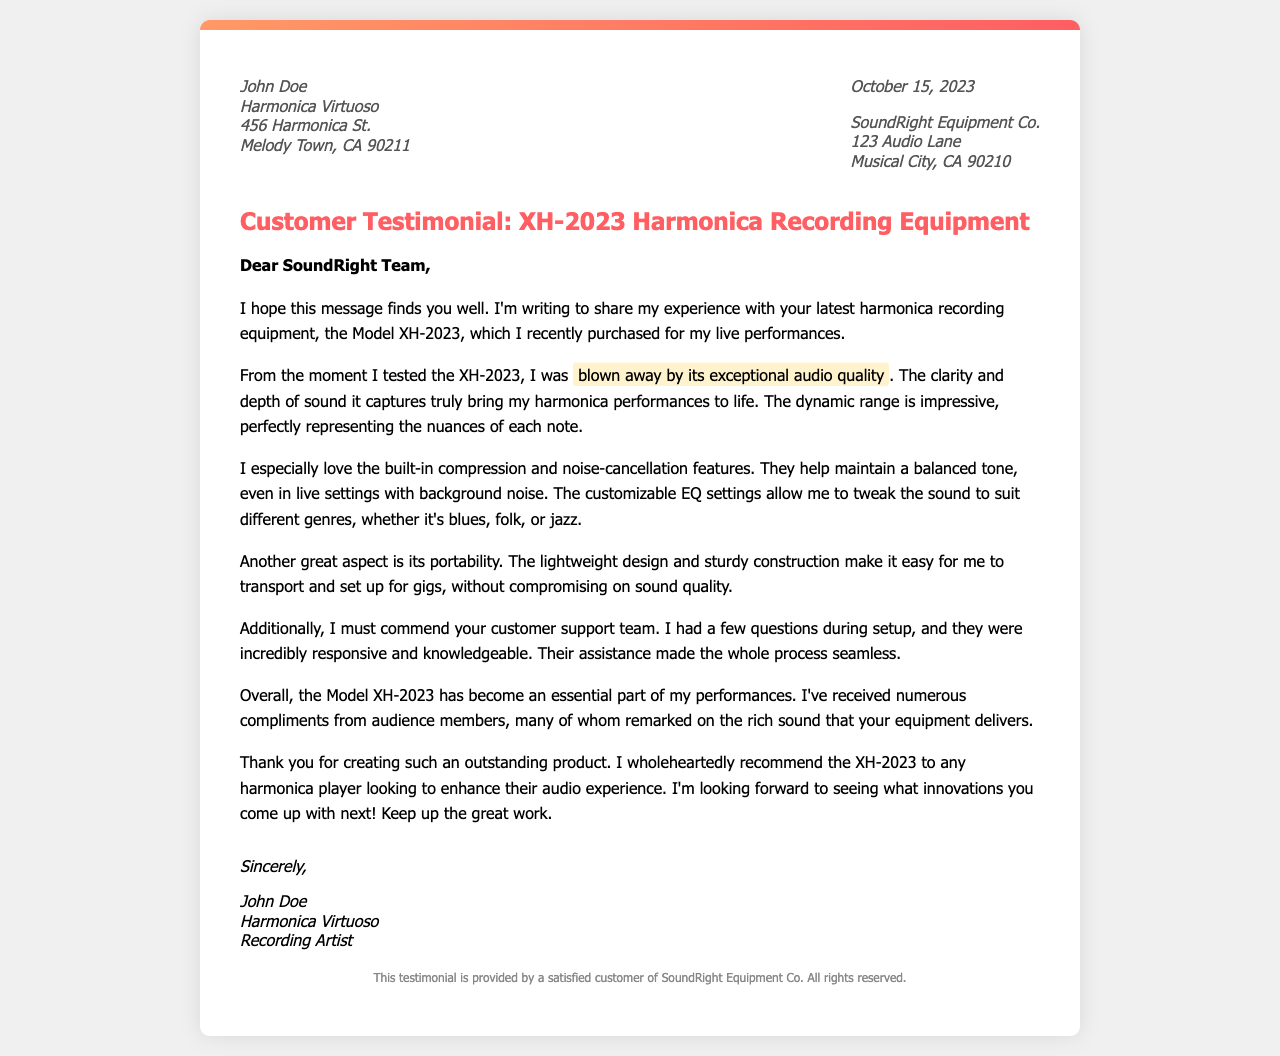What is the name of the testimonial author? The testimonial author is John Doe, as stated at the beginning of the letter.
Answer: John Doe What is the model of the recording equipment mentioned? The recording equipment mentioned in the letter is the Model XH-2023.
Answer: XH-2023 What features of the XH-2023 are highlighted in the testimonial? The notable features include exceptional audio quality, built-in compression, noise-cancellation, and customizable EQ settings, as mentioned in the content.
Answer: Exceptional audio quality, built-in compression, noise-cancellation, customizable EQ settings When was the testimonial written? The date mentioned in the letter is October 15, 2023.
Answer: October 15, 2023 Who is the intended recipient of the letter? The letter is addressed to the SoundRight Team, indicating that they are the recipients.
Answer: SoundRight Team What does the author express gratitude for in the letter? The author expresses gratitude for creating an outstanding product, specifically mentioning the Model XH-2023 harmonica recording equipment.
Answer: Outstanding product How does the author describe the customer support received? The author describes the customer support as incredibly responsive and knowledgeable during the setup process.
Answer: Incredibly responsive and knowledgeable What is the primary genre of music the author plays? The author mentions blues, folk, or jazz as the genres in which they utilize the recording equipment.
Answer: Blues, folk, or jazz What is a notable aspect of the XH-2023 related to its physical design? The author notes that the XH-2023 is portable, highlighting its lightweight design and sturdy construction.
Answer: Portable, lightweight design, sturdy construction 